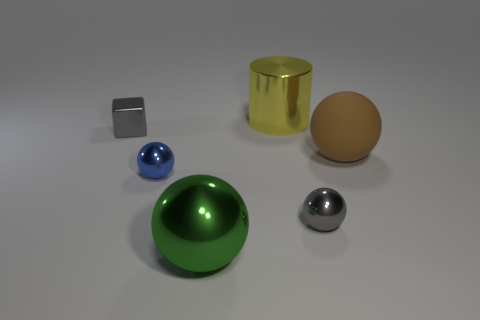Subtract all matte spheres. How many spheres are left? 3 Add 3 tiny brown matte cubes. How many objects exist? 9 Subtract all blue spheres. How many spheres are left? 3 Subtract all cubes. How many objects are left? 5 Subtract 2 balls. How many balls are left? 2 Subtract all large yellow metallic cylinders. Subtract all large balls. How many objects are left? 3 Add 3 large yellow cylinders. How many large yellow cylinders are left? 4 Add 4 blue shiny spheres. How many blue shiny spheres exist? 5 Subtract 0 cyan balls. How many objects are left? 6 Subtract all brown spheres. Subtract all purple cylinders. How many spheres are left? 3 